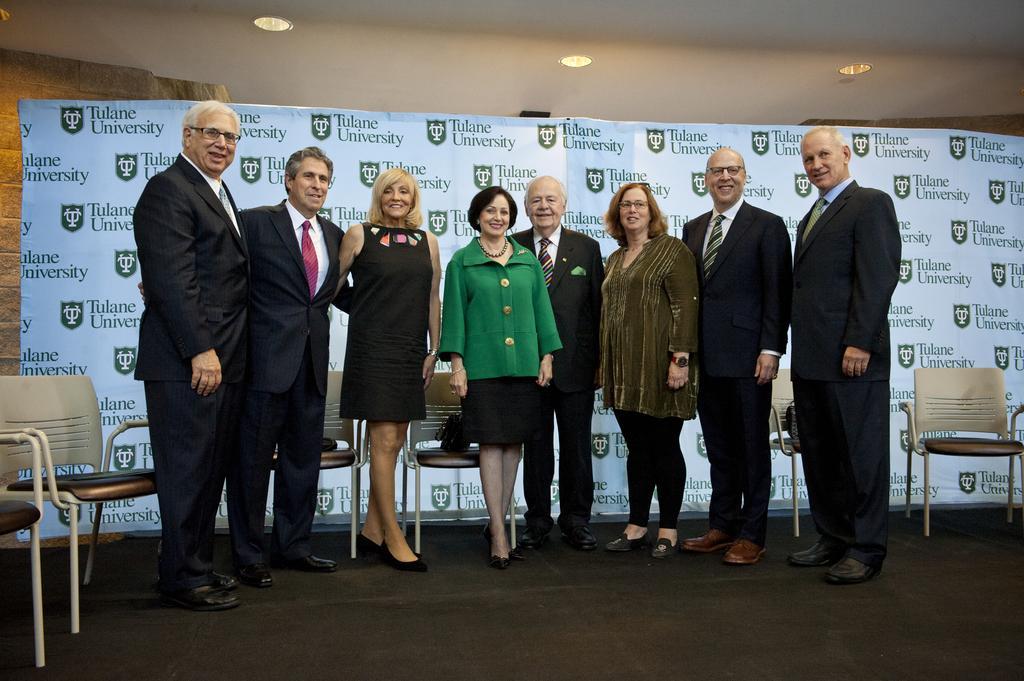Can you describe this image briefly? In this picture there is a woman who is wearing green jacket, short and show, standing near to the man who is wearing suits. On the left there are two man was standing near to this woman who is wearing black dress. Everyone is standing near to the chairs. At the back there is a banner. At the top we can see lights. 